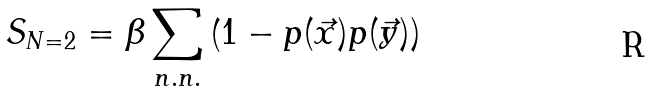Convert formula to latex. <formula><loc_0><loc_0><loc_500><loc_500>S _ { N = 2 } = \beta \sum _ { n . n . } \left ( 1 - p ( \vec { x } ) p ( \vec { y } ) \right )</formula> 